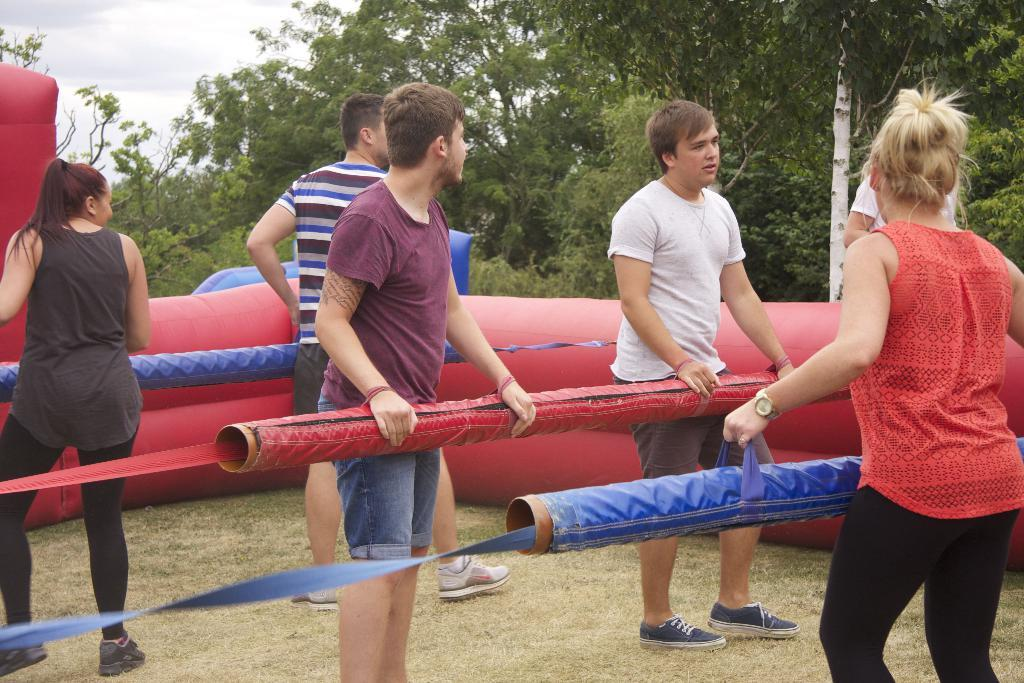How many people are in the image? There is a group of people in the image, but the exact number is not specified. What are the people holding in the image? The people are holding cylindrical-shaped objects. What type of object can be seen in the image that is inflatable? There is an inflatable object in the image. What type of natural environment is visible in the image? There are trees in the image, indicating a natural environment. What is visible in the background of the image? The sky is visible in the background of the image. Where is the drawer located in the image? There is no drawer present in the image. What type of control is being used by the people in the image? The cylindrical-shaped objects being held by the people do not appear to be controls, so it is not possible to determine what type of control is being used. 